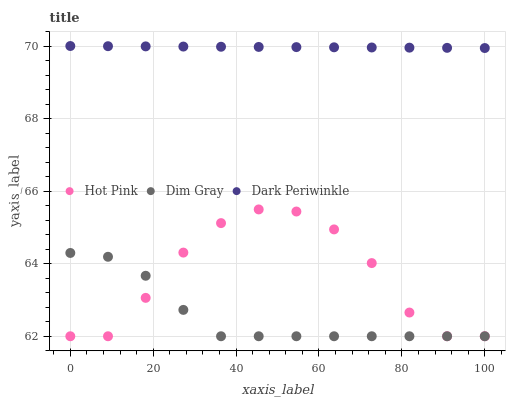Does Dim Gray have the minimum area under the curve?
Answer yes or no. Yes. Does Dark Periwinkle have the maximum area under the curve?
Answer yes or no. Yes. Does Hot Pink have the minimum area under the curve?
Answer yes or no. No. Does Hot Pink have the maximum area under the curve?
Answer yes or no. No. Is Dark Periwinkle the smoothest?
Answer yes or no. Yes. Is Hot Pink the roughest?
Answer yes or no. Yes. Is Hot Pink the smoothest?
Answer yes or no. No. Is Dark Periwinkle the roughest?
Answer yes or no. No. Does Dim Gray have the lowest value?
Answer yes or no. Yes. Does Dark Periwinkle have the lowest value?
Answer yes or no. No. Does Dark Periwinkle have the highest value?
Answer yes or no. Yes. Does Hot Pink have the highest value?
Answer yes or no. No. Is Hot Pink less than Dark Periwinkle?
Answer yes or no. Yes. Is Dark Periwinkle greater than Hot Pink?
Answer yes or no. Yes. Does Dim Gray intersect Hot Pink?
Answer yes or no. Yes. Is Dim Gray less than Hot Pink?
Answer yes or no. No. Is Dim Gray greater than Hot Pink?
Answer yes or no. No. Does Hot Pink intersect Dark Periwinkle?
Answer yes or no. No. 